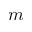<formula> <loc_0><loc_0><loc_500><loc_500>m</formula> 